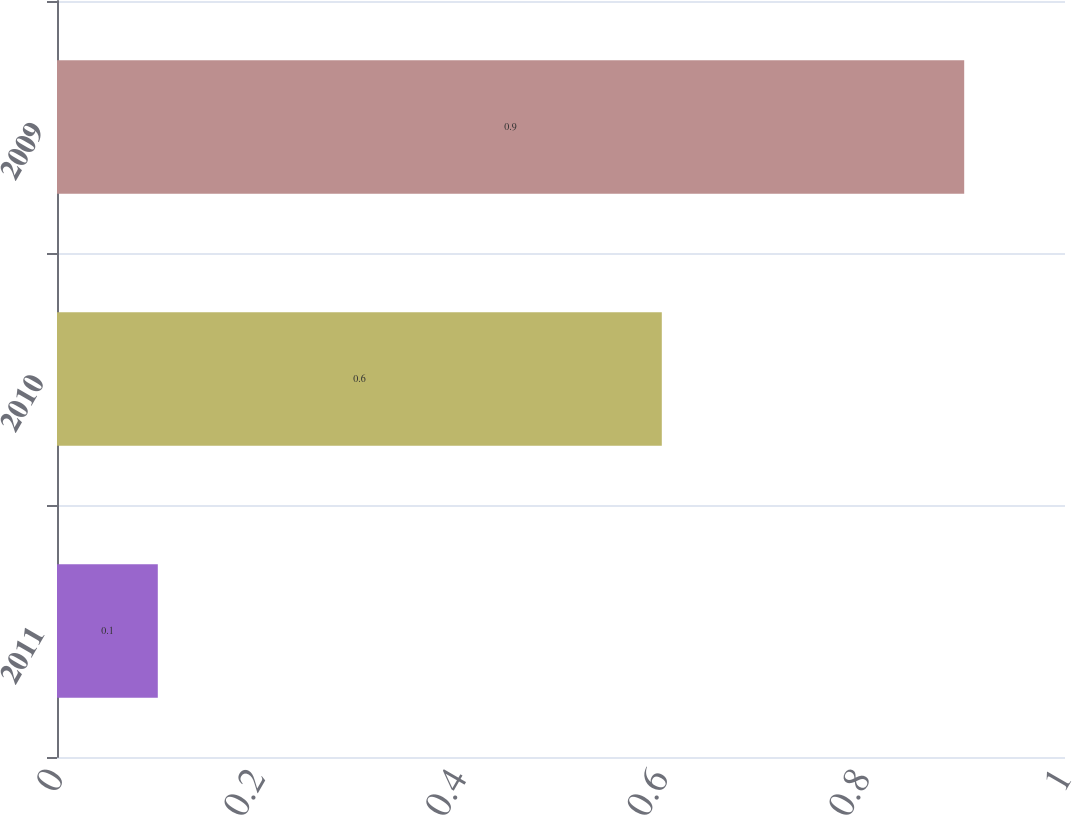Convert chart. <chart><loc_0><loc_0><loc_500><loc_500><bar_chart><fcel>2011<fcel>2010<fcel>2009<nl><fcel>0.1<fcel>0.6<fcel>0.9<nl></chart> 